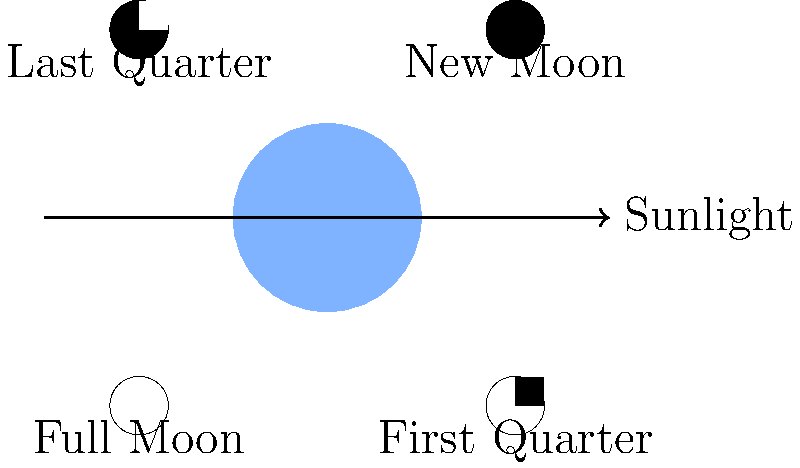As a tech journalist writing about cybersecurity, you're researching the connection between lunar phases and satellite vulnerabilities. Which phase of the Moon would provide the most illumination for Earth-based observations of satellites, potentially increasing their susceptibility to optical interception? To answer this question, we need to understand the phases of the Moon and their relationship to Earth-based illumination:

1. New Moon: The side of the Moon facing Earth is completely dark, providing no illumination.

2. First Quarter: Half of the Moon's visible surface is illuminated, providing moderate illumination.

3. Full Moon: The entire visible surface of the Moon facing Earth is illuminated, providing maximum illumination.

4. Last Quarter: Similar to First Quarter, with half of the visible surface illuminated.

The Full Moon phase provides the most illumination because:

a) The entire Earth-facing side of the Moon is reflecting sunlight.
b) This results in the brightest nighttime conditions on Earth.
c) Increased illumination can make satellites more visible and potentially more vulnerable to optical interception or observation.

For cybersecurity implications, the Full Moon phase could theoretically increase the risk of optical-based surveillance or interception of satellites, as they may be more easily visible against the brighter night sky.
Answer: Full Moon 